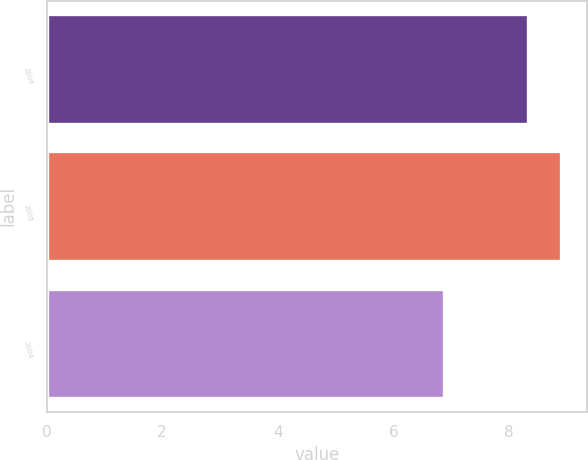Convert chart to OTSL. <chart><loc_0><loc_0><loc_500><loc_500><bar_chart><fcel>2006<fcel>2005<fcel>2004<nl><fcel>8.32<fcel>8.9<fcel>6.88<nl></chart> 